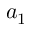<formula> <loc_0><loc_0><loc_500><loc_500>a _ { 1 }</formula> 